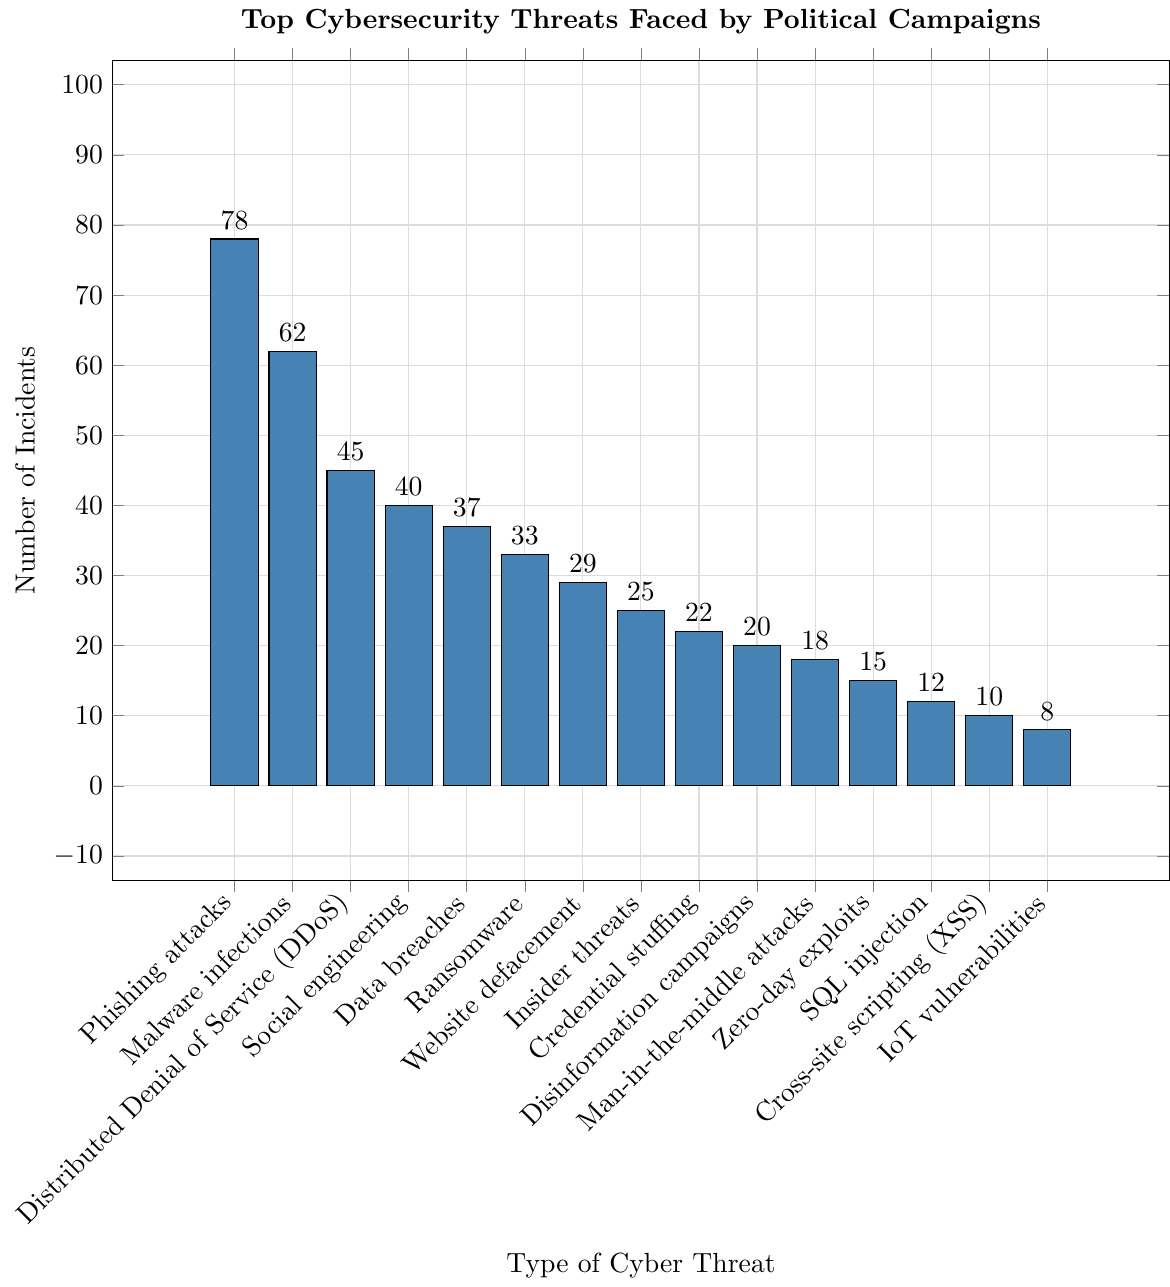What is the most common cybersecurity threat faced by political campaigns? The bar chart shows various types of cybersecurity threats, and the tallest bar represents the most common threat. "Phishing attacks" has the tallest bar with 78 incidents, making it the most common threat.
Answer: Phishing attacks How many more incidents of phishing attacks are there compared to malware infections? The bar for "Phishing attacks" shows 78 incidents, and the bar for "Malware infections" shows 62 incidents. The difference between them is 78 - 62 = 16.
Answer: 16 What is the total number of incidents for "Disinformation campaigns," "Man-in-the-middle attacks," and "IoT vulnerabilities"? Add the incidents for each: Disinformation campaigns (20) + Man-in-the-middle attacks (18) + IoT vulnerabilities (8). The total is 20 + 18 + 8 = 46.
Answer: 46 Which cyber threat among "Insider threats" and "Credential stuffing" is more frequent, and by how many incidents? The chart shows that "Insider threats" had 25 incidents and "Credential stuffing" had 22 incidents. Therefore, "Insider threats" is more frequent by 25 - 22 = 3 incidents.
Answer: Insider threats by 3 incidents Are there more or fewer incidents of "Social engineering" compared to "Data breaches?" The bar for "Social engineering" shows 40 incidents, and the bar for "Data breaches" shows 37 incidents. Therefore, "Social engineering" has more incidents.
Answer: More What is the combined total of incidents for all the threats shown in the chart? Sum up all the incidents across the different threats: 78 + 62 + 45 + 40 + 37 + 33 + 29 + 25 + 22 + 20 + 18 + 15 + 12 + 10 + 8. The total is 454.
Answer: 454 How many incidents did "Website defacement" have, and how does it compare to "Ransomware"? "Website defacement" shows 29 incidents, while "Ransomware" shows 33 incidents. To compare, 33 - 29 = 4, so "Ransomware" had 4 more incidents.
Answer: 29 incidents, 4 fewer than Ransomware What is the least common cybersecurity threat, and how many incidents does it have? The shortest bar represents the least common threat, which is "IoT vulnerabilities" with 8 incidents.
Answer: IoT vulnerabilities, 8 Calculate the average number of incidents for the threats "DDoS," "Social engineering," and "Data breaches." Add the incidents for the three threats: DDoS (45) + Social engineering (40) + Data breaches (37). The sum is 122. The average is 122 / 3 ≈ 40.67.
Answer: 40.67 